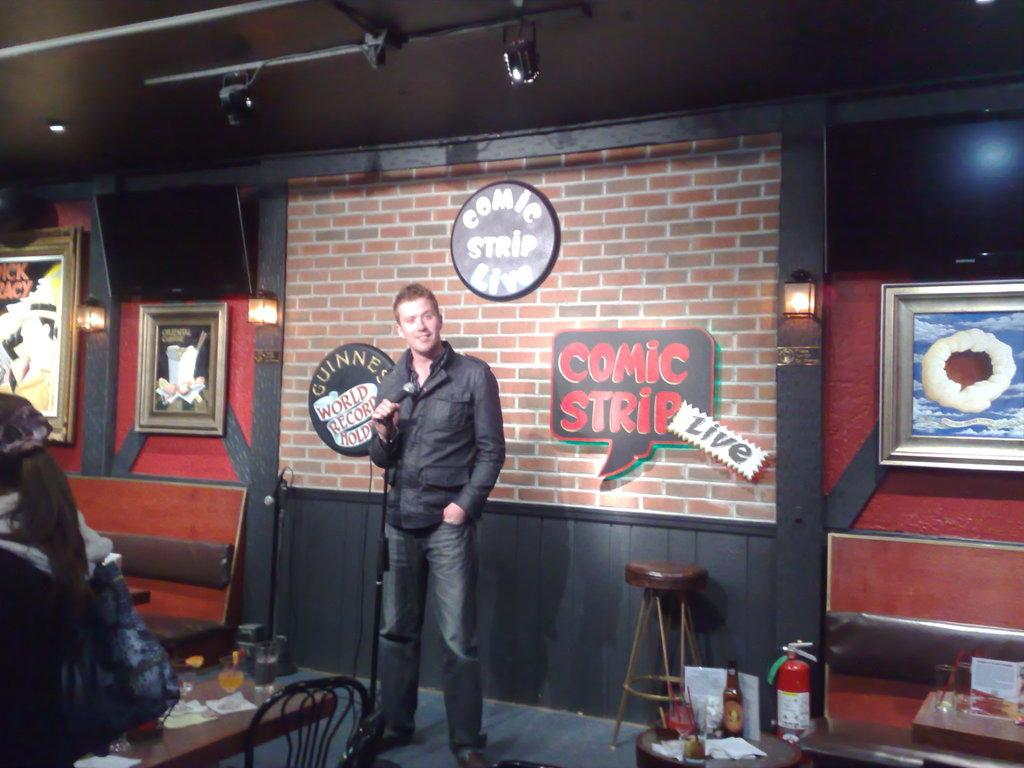What is the man in the image doing? The man is standing and holding a microphone. What objects can be seen in the background of the image? There is a table, a chair, a bottle, an oxygen cylinder, a frame attached to the wall, a light, and a television in the background of the image. Can you describe the objects on the table? The facts provided do not specify the objects on the table. What type of light is present in the background of the image? The facts provided do not specify the type of light. What type of friction can be observed between the man and the volcano in the image? There is no volcano present in the image, so there is no friction between the man and a volcano. 